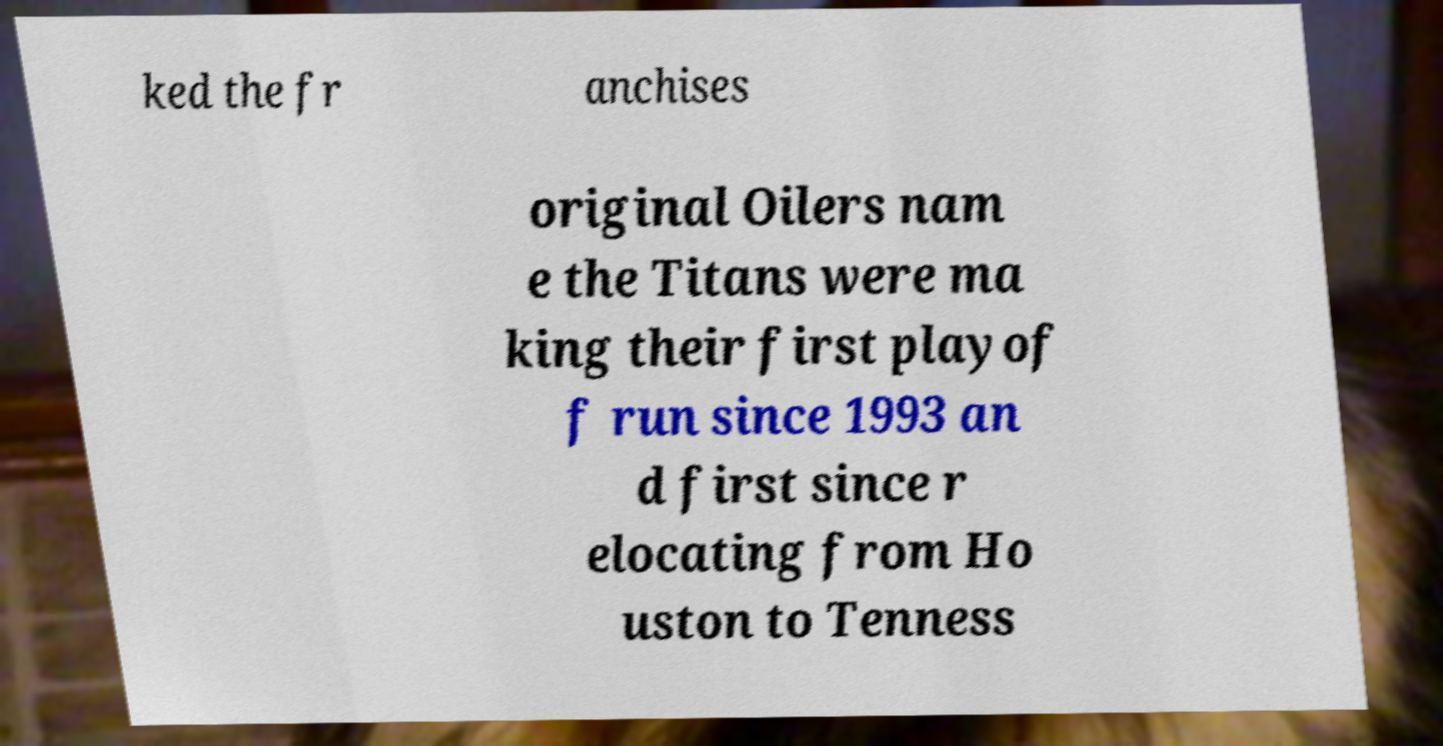Could you assist in decoding the text presented in this image and type it out clearly? ked the fr anchises original Oilers nam e the Titans were ma king their first playof f run since 1993 an d first since r elocating from Ho uston to Tenness 